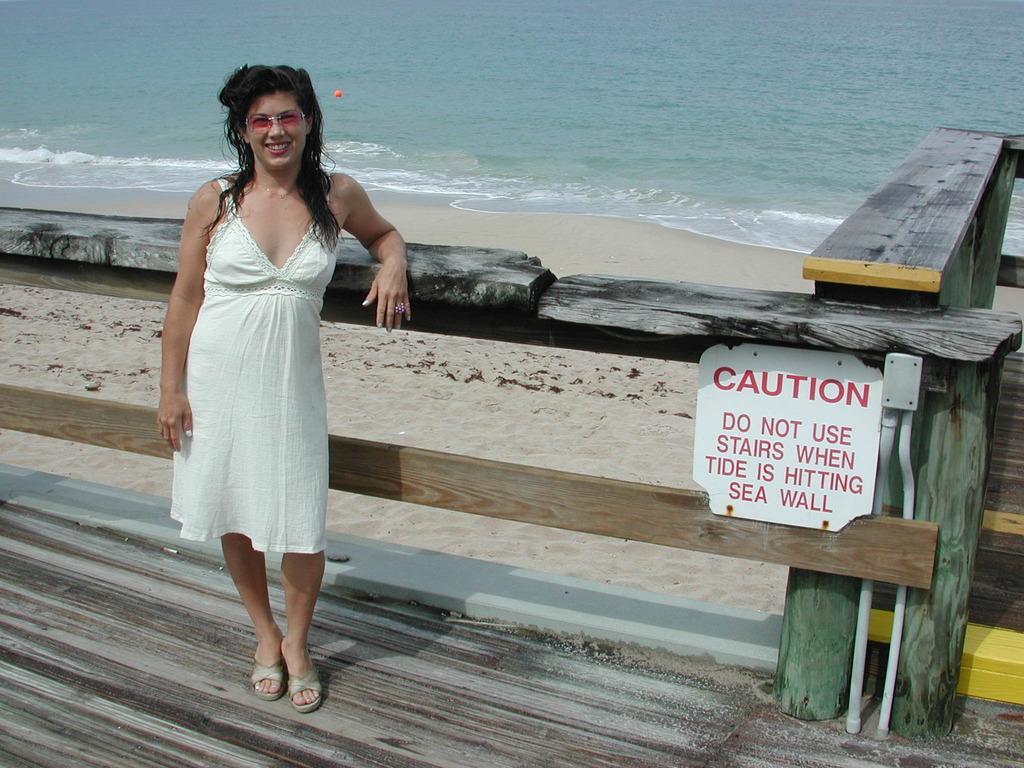In one or two sentences, can you explain what this image depicts? In this image we can see a sea. There is a beach in the image. A lady is standing on the wooden surface. There is a fencing in the image. 